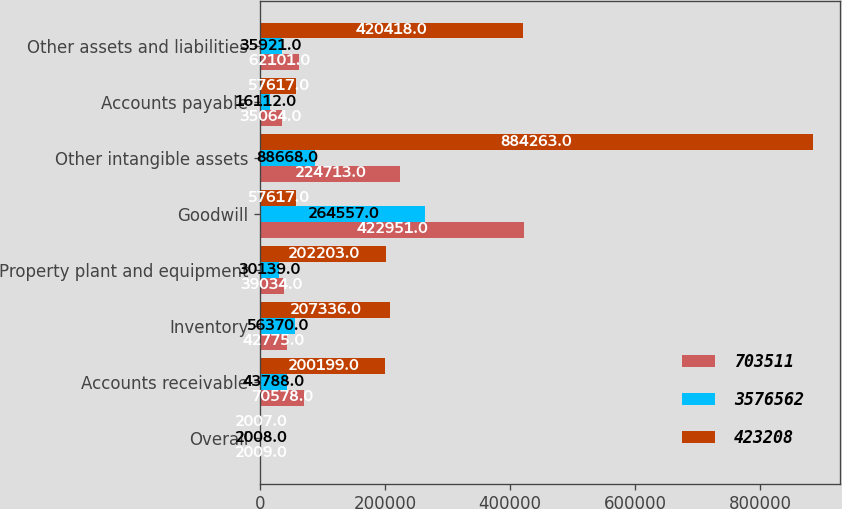Convert chart to OTSL. <chart><loc_0><loc_0><loc_500><loc_500><stacked_bar_chart><ecel><fcel>Overall<fcel>Accounts receivable<fcel>Inventory<fcel>Property plant and equipment<fcel>Goodwill<fcel>Other intangible assets<fcel>Accounts payable<fcel>Other assets and liabilities<nl><fcel>703511<fcel>2009<fcel>70578<fcel>42775<fcel>39034<fcel>422951<fcel>224713<fcel>35064<fcel>62101<nl><fcel>3.57656e+06<fcel>2008<fcel>43788<fcel>56370<fcel>30139<fcel>264557<fcel>88668<fcel>16112<fcel>35921<nl><fcel>423208<fcel>2007<fcel>200199<fcel>207336<fcel>202203<fcel>57617<fcel>884263<fcel>57617<fcel>420418<nl></chart> 